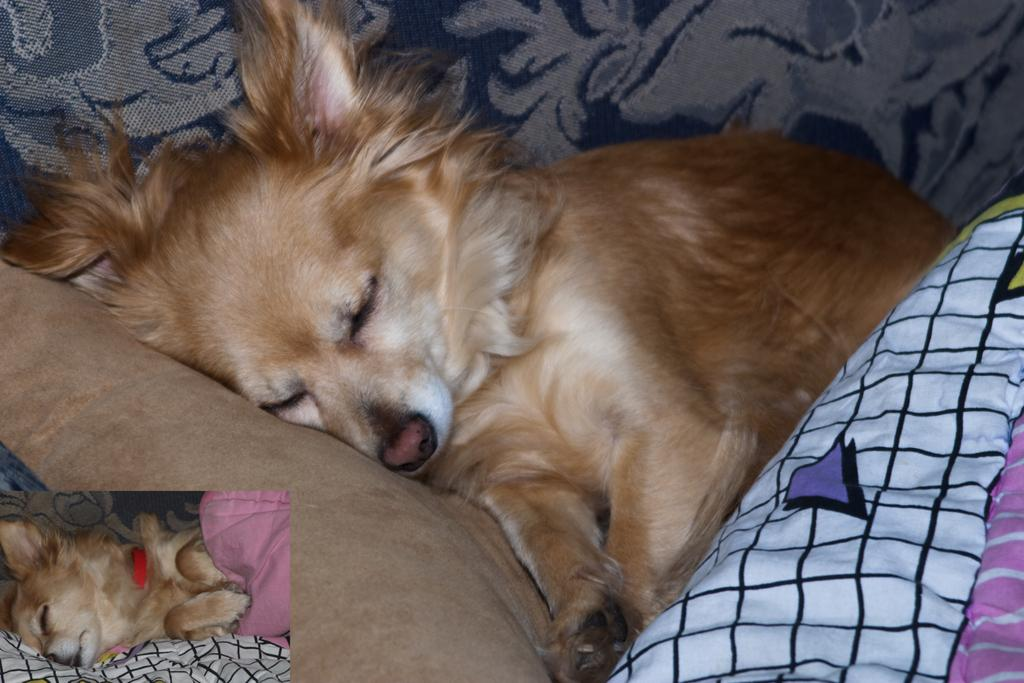What type of animal is in the image? There is a brown dog in the image. What is the dog doing in the image? The dog is sleeping on a couch. What color is the couch? The couch is blue. What is placed in front of the couch? There are blankets in front of the couch. What colors are present on the blankets? The blankets have brown, white, and black colors. What type of button can be seen on the dog's collar in the image? There is no button visible on the dog's collar in the image. Can you tell me how many cups of coffee the dog is holding in the image? The dog is not holding any cups of coffee in the image. 